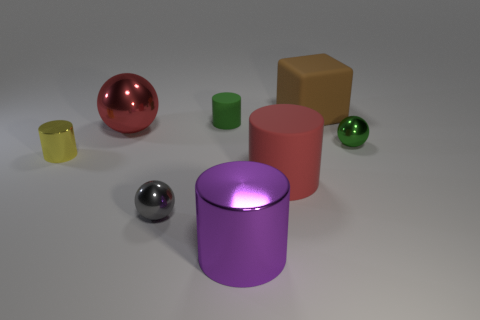Subtract 1 cylinders. How many cylinders are left? 3 Add 1 big cylinders. How many objects exist? 9 Subtract all blocks. How many objects are left? 7 Subtract 0 brown cylinders. How many objects are left? 8 Subtract all red rubber things. Subtract all purple cylinders. How many objects are left? 6 Add 6 green metal spheres. How many green metal spheres are left? 7 Add 7 gray metallic spheres. How many gray metallic spheres exist? 8 